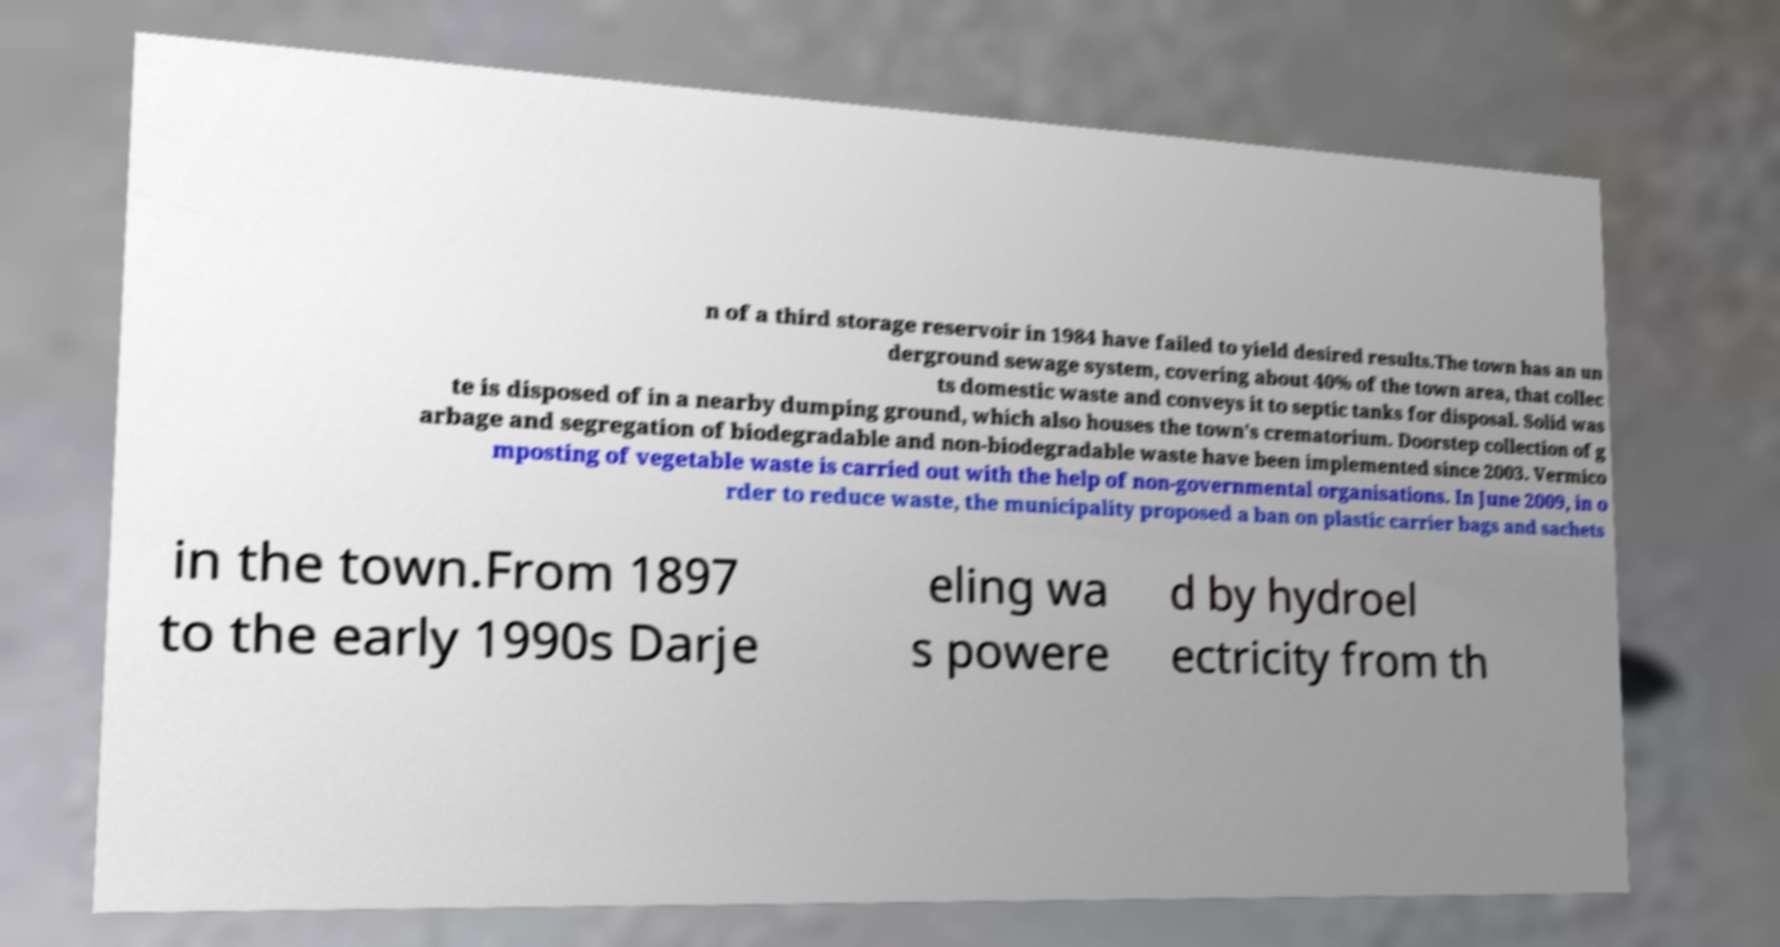I need the written content from this picture converted into text. Can you do that? n of a third storage reservoir in 1984 have failed to yield desired results.The town has an un derground sewage system, covering about 40% of the town area, that collec ts domestic waste and conveys it to septic tanks for disposal. Solid was te is disposed of in a nearby dumping ground, which also houses the town's crematorium. Doorstep collection of g arbage and segregation of biodegradable and non-biodegradable waste have been implemented since 2003. Vermico mposting of vegetable waste is carried out with the help of non-governmental organisations. In June 2009, in o rder to reduce waste, the municipality proposed a ban on plastic carrier bags and sachets in the town.From 1897 to the early 1990s Darje eling wa s powere d by hydroel ectricity from th 